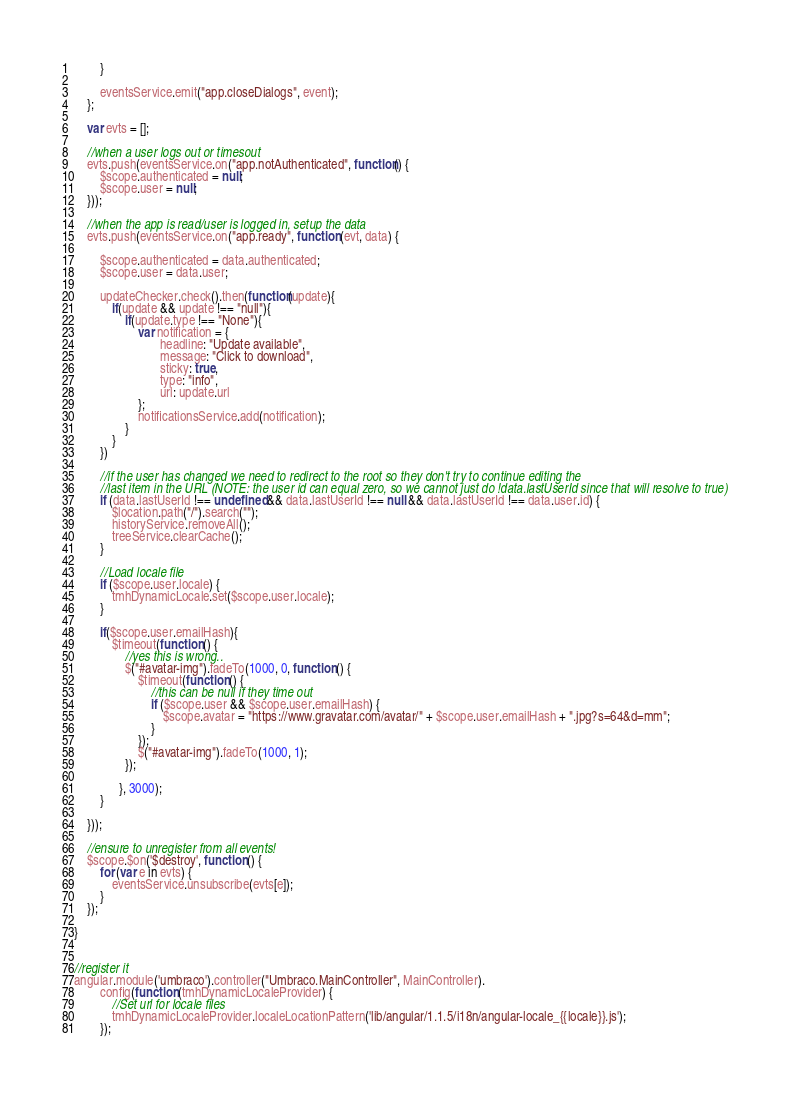<code> <loc_0><loc_0><loc_500><loc_500><_JavaScript_>        }

        eventsService.emit("app.closeDialogs", event);
    };

    var evts = [];

    //when a user logs out or timesout
    evts.push(eventsService.on("app.notAuthenticated", function() {
        $scope.authenticated = null;
        $scope.user = null;
    }));
    
    //when the app is read/user is logged in, setup the data
    evts.push(eventsService.on("app.ready", function (evt, data) {
        
        $scope.authenticated = data.authenticated;
        $scope.user = data.user;

        updateChecker.check().then(function(update){
            if(update && update !== "null"){
                if(update.type !== "None"){
                    var notification = {
                           headline: "Update available",
                           message: "Click to download",
                           sticky: true,
                           type: "info",
                           url: update.url
                    };
                    notificationsService.add(notification);
                }
            }
        })

        //if the user has changed we need to redirect to the root so they don't try to continue editing the
        //last item in the URL (NOTE: the user id can equal zero, so we cannot just do !data.lastUserId since that will resolve to true)
        if (data.lastUserId !== undefined && data.lastUserId !== null && data.lastUserId !== data.user.id) {
            $location.path("/").search("");
            historyService.removeAll();
            treeService.clearCache();
        }

        //Load locale file
        if ($scope.user.locale) {
            tmhDynamicLocale.set($scope.user.locale);
        }

        if($scope.user.emailHash){
            $timeout(function () {                
                //yes this is wrong.. 
                $("#avatar-img").fadeTo(1000, 0, function () {
                    $timeout(function () {
                        //this can be null if they time out
                        if ($scope.user && $scope.user.emailHash) {
                            $scope.avatar = "https://www.gravatar.com/avatar/" + $scope.user.emailHash + ".jpg?s=64&d=mm";
                        }
                    });
                    $("#avatar-img").fadeTo(1000, 1);
                });
                
              }, 3000);  
        }

    }));

    //ensure to unregister from all events!
    $scope.$on('$destroy', function () {
        for (var e in evts) {
            eventsService.unsubscribe(evts[e]);
        }
    });

}


//register it
angular.module('umbraco').controller("Umbraco.MainController", MainController).
        config(function (tmhDynamicLocaleProvider) {
            //Set url for locale files
            tmhDynamicLocaleProvider.localeLocationPattern('lib/angular/1.1.5/i18n/angular-locale_{{locale}}.js');
        });</code> 